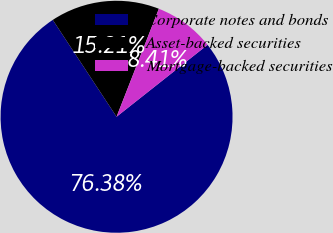Convert chart to OTSL. <chart><loc_0><loc_0><loc_500><loc_500><pie_chart><fcel>Corporate notes and bonds<fcel>Asset-backed securities<fcel>Mortgage-backed securities<nl><fcel>76.37%<fcel>15.21%<fcel>8.41%<nl></chart> 